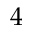<formula> <loc_0><loc_0><loc_500><loc_500>4</formula> 